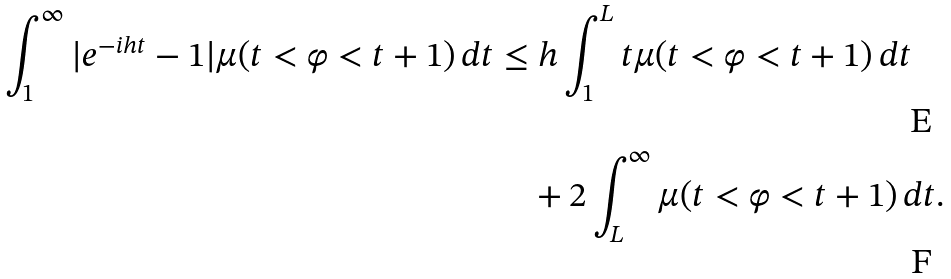Convert formula to latex. <formula><loc_0><loc_0><loc_500><loc_500>\int _ { 1 } ^ { \infty } | e ^ { - i h t } - 1 | \mu ( t < \varphi < t + 1 ) \, d t & \leq h \int _ { 1 } ^ { L } t \mu ( t < \varphi < t + 1 ) \, d t \\ & \quad + 2 \int _ { L } ^ { \infty } \mu ( t < \varphi < t + 1 ) \, d t .</formula> 